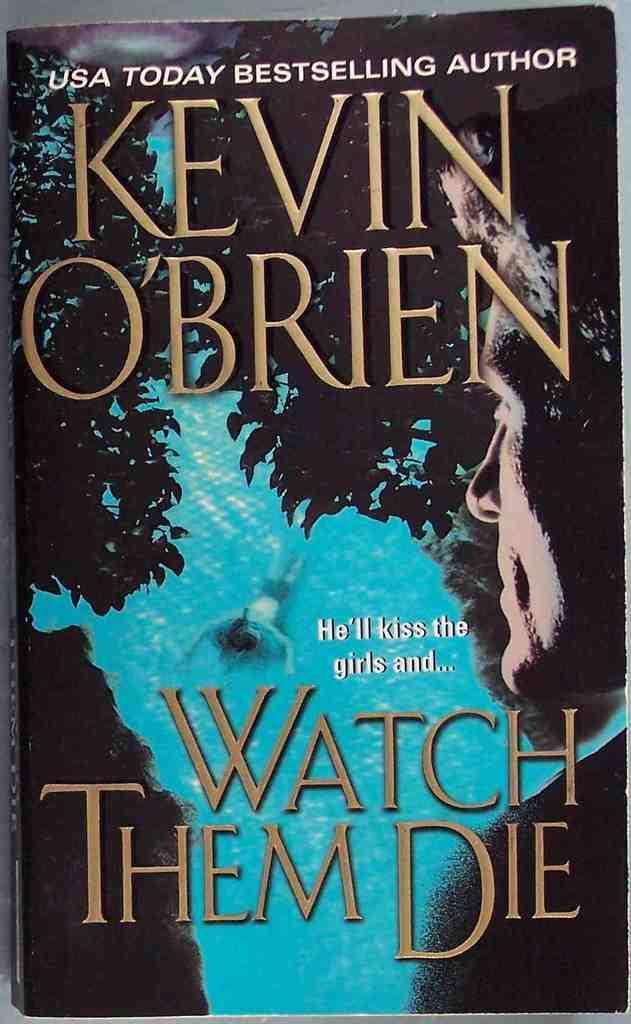Could you give a brief overview of what you see in this image? In this image we can see a book cover which consists of some text and images on it. 